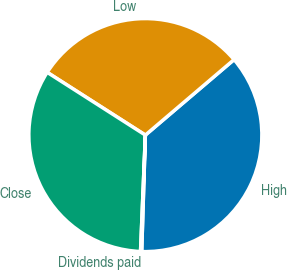Convert chart to OTSL. <chart><loc_0><loc_0><loc_500><loc_500><pie_chart><fcel>High<fcel>Low<fcel>Close<fcel>Dividends paid<nl><fcel>36.72%<fcel>29.72%<fcel>33.39%<fcel>0.16%<nl></chart> 